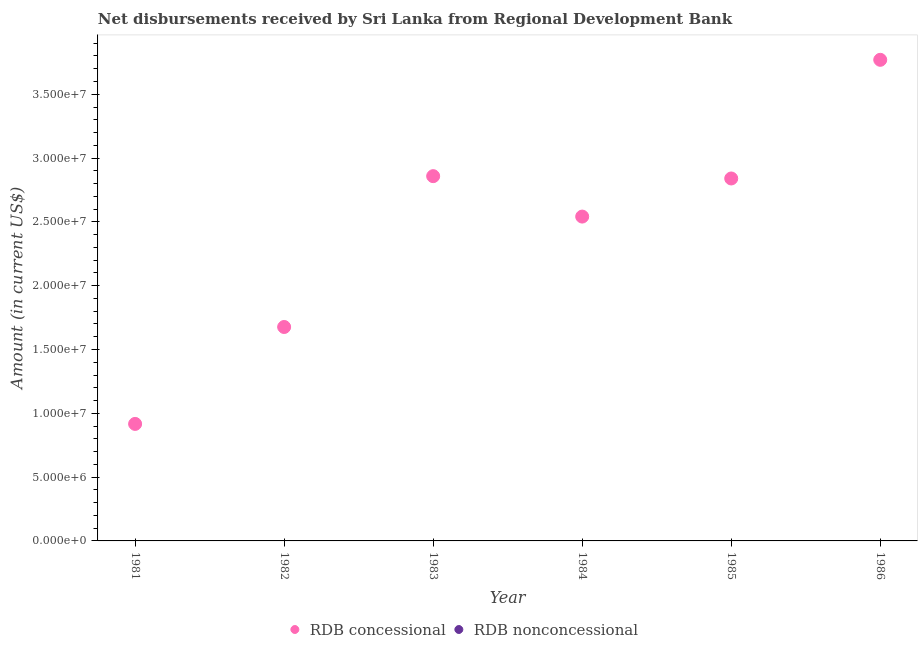Is the number of dotlines equal to the number of legend labels?
Your answer should be very brief. No. What is the net concessional disbursements from rdb in 1982?
Your response must be concise. 1.68e+07. Across all years, what is the maximum net concessional disbursements from rdb?
Offer a very short reply. 3.77e+07. Across all years, what is the minimum net concessional disbursements from rdb?
Give a very brief answer. 9.17e+06. In which year was the net concessional disbursements from rdb maximum?
Ensure brevity in your answer.  1986. What is the total net non concessional disbursements from rdb in the graph?
Keep it short and to the point. 0. What is the difference between the net concessional disbursements from rdb in 1982 and that in 1984?
Keep it short and to the point. -8.65e+06. What is the difference between the net concessional disbursements from rdb in 1986 and the net non concessional disbursements from rdb in 1984?
Ensure brevity in your answer.  3.77e+07. What is the ratio of the net concessional disbursements from rdb in 1985 to that in 1986?
Keep it short and to the point. 0.75. Is the net concessional disbursements from rdb in 1981 less than that in 1986?
Offer a very short reply. Yes. What is the difference between the highest and the second highest net concessional disbursements from rdb?
Keep it short and to the point. 9.12e+06. What is the difference between the highest and the lowest net concessional disbursements from rdb?
Keep it short and to the point. 2.85e+07. In how many years, is the net concessional disbursements from rdb greater than the average net concessional disbursements from rdb taken over all years?
Your response must be concise. 4. Is the net non concessional disbursements from rdb strictly greater than the net concessional disbursements from rdb over the years?
Your answer should be very brief. No. Is the net concessional disbursements from rdb strictly less than the net non concessional disbursements from rdb over the years?
Offer a terse response. No. Does the graph contain any zero values?
Keep it short and to the point. Yes. Where does the legend appear in the graph?
Your answer should be compact. Bottom center. How many legend labels are there?
Ensure brevity in your answer.  2. What is the title of the graph?
Give a very brief answer. Net disbursements received by Sri Lanka from Regional Development Bank. Does "Register a business" appear as one of the legend labels in the graph?
Your answer should be compact. No. What is the label or title of the X-axis?
Provide a short and direct response. Year. What is the Amount (in current US$) in RDB concessional in 1981?
Your answer should be very brief. 9.17e+06. What is the Amount (in current US$) of RDB nonconcessional in 1981?
Make the answer very short. 0. What is the Amount (in current US$) of RDB concessional in 1982?
Your answer should be very brief. 1.68e+07. What is the Amount (in current US$) in RDB concessional in 1983?
Offer a terse response. 2.86e+07. What is the Amount (in current US$) in RDB nonconcessional in 1983?
Your answer should be very brief. 0. What is the Amount (in current US$) in RDB concessional in 1984?
Provide a short and direct response. 2.54e+07. What is the Amount (in current US$) in RDB concessional in 1985?
Provide a short and direct response. 2.84e+07. What is the Amount (in current US$) of RDB nonconcessional in 1985?
Provide a short and direct response. 0. What is the Amount (in current US$) of RDB concessional in 1986?
Give a very brief answer. 3.77e+07. What is the Amount (in current US$) of RDB nonconcessional in 1986?
Provide a succinct answer. 0. Across all years, what is the maximum Amount (in current US$) of RDB concessional?
Make the answer very short. 3.77e+07. Across all years, what is the minimum Amount (in current US$) of RDB concessional?
Your response must be concise. 9.17e+06. What is the total Amount (in current US$) of RDB concessional in the graph?
Make the answer very short. 1.46e+08. What is the total Amount (in current US$) of RDB nonconcessional in the graph?
Offer a very short reply. 0. What is the difference between the Amount (in current US$) in RDB concessional in 1981 and that in 1982?
Make the answer very short. -7.59e+06. What is the difference between the Amount (in current US$) in RDB concessional in 1981 and that in 1983?
Ensure brevity in your answer.  -1.94e+07. What is the difference between the Amount (in current US$) of RDB concessional in 1981 and that in 1984?
Keep it short and to the point. -1.62e+07. What is the difference between the Amount (in current US$) of RDB concessional in 1981 and that in 1985?
Give a very brief answer. -1.92e+07. What is the difference between the Amount (in current US$) of RDB concessional in 1981 and that in 1986?
Provide a short and direct response. -2.85e+07. What is the difference between the Amount (in current US$) of RDB concessional in 1982 and that in 1983?
Make the answer very short. -1.18e+07. What is the difference between the Amount (in current US$) in RDB concessional in 1982 and that in 1984?
Offer a terse response. -8.65e+06. What is the difference between the Amount (in current US$) of RDB concessional in 1982 and that in 1985?
Ensure brevity in your answer.  -1.16e+07. What is the difference between the Amount (in current US$) in RDB concessional in 1982 and that in 1986?
Make the answer very short. -2.09e+07. What is the difference between the Amount (in current US$) of RDB concessional in 1983 and that in 1984?
Provide a short and direct response. 3.17e+06. What is the difference between the Amount (in current US$) in RDB concessional in 1983 and that in 1985?
Offer a very short reply. 1.82e+05. What is the difference between the Amount (in current US$) in RDB concessional in 1983 and that in 1986?
Make the answer very short. -9.12e+06. What is the difference between the Amount (in current US$) of RDB concessional in 1984 and that in 1985?
Give a very brief answer. -2.99e+06. What is the difference between the Amount (in current US$) in RDB concessional in 1984 and that in 1986?
Provide a short and direct response. -1.23e+07. What is the difference between the Amount (in current US$) of RDB concessional in 1985 and that in 1986?
Make the answer very short. -9.30e+06. What is the average Amount (in current US$) of RDB concessional per year?
Your answer should be compact. 2.43e+07. What is the ratio of the Amount (in current US$) in RDB concessional in 1981 to that in 1982?
Keep it short and to the point. 0.55. What is the ratio of the Amount (in current US$) in RDB concessional in 1981 to that in 1983?
Ensure brevity in your answer.  0.32. What is the ratio of the Amount (in current US$) in RDB concessional in 1981 to that in 1984?
Keep it short and to the point. 0.36. What is the ratio of the Amount (in current US$) in RDB concessional in 1981 to that in 1985?
Your response must be concise. 0.32. What is the ratio of the Amount (in current US$) in RDB concessional in 1981 to that in 1986?
Provide a succinct answer. 0.24. What is the ratio of the Amount (in current US$) of RDB concessional in 1982 to that in 1983?
Keep it short and to the point. 0.59. What is the ratio of the Amount (in current US$) of RDB concessional in 1982 to that in 1984?
Your response must be concise. 0.66. What is the ratio of the Amount (in current US$) in RDB concessional in 1982 to that in 1985?
Your answer should be very brief. 0.59. What is the ratio of the Amount (in current US$) in RDB concessional in 1982 to that in 1986?
Give a very brief answer. 0.44. What is the ratio of the Amount (in current US$) of RDB concessional in 1983 to that in 1984?
Provide a short and direct response. 1.12. What is the ratio of the Amount (in current US$) in RDB concessional in 1983 to that in 1985?
Your answer should be compact. 1.01. What is the ratio of the Amount (in current US$) in RDB concessional in 1983 to that in 1986?
Give a very brief answer. 0.76. What is the ratio of the Amount (in current US$) in RDB concessional in 1984 to that in 1985?
Offer a terse response. 0.89. What is the ratio of the Amount (in current US$) in RDB concessional in 1984 to that in 1986?
Offer a terse response. 0.67. What is the ratio of the Amount (in current US$) in RDB concessional in 1985 to that in 1986?
Your response must be concise. 0.75. What is the difference between the highest and the second highest Amount (in current US$) of RDB concessional?
Provide a short and direct response. 9.12e+06. What is the difference between the highest and the lowest Amount (in current US$) of RDB concessional?
Your response must be concise. 2.85e+07. 